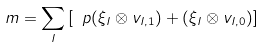<formula> <loc_0><loc_0><loc_500><loc_500>m = \sum _ { I } \left [ \ p ( \xi _ { I } \otimes v _ { I , 1 } ) + ( \xi _ { I } \otimes v _ { I , 0 } ) \right ]</formula> 